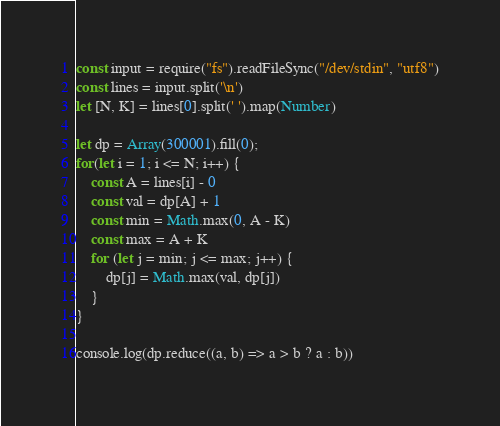Convert code to text. <code><loc_0><loc_0><loc_500><loc_500><_JavaScript_>const input = require("fs").readFileSync("/dev/stdin", "utf8")
const lines = input.split('\n')
let [N, K] = lines[0].split(' ').map(Number)

let dp = Array(300001).fill(0);
for(let i = 1; i <= N; i++) {
    const A = lines[i] - 0
    const val = dp[A] + 1
    const min = Math.max(0, A - K)
    const max = A + K
    for (let j = min; j <= max; j++) {
        dp[j] = Math.max(val, dp[j])
    }
}

console.log(dp.reduce((a, b) => a > b ? a : b))
</code> 